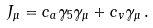Convert formula to latex. <formula><loc_0><loc_0><loc_500><loc_500>J _ { \mu } = c _ { a } \gamma _ { 5 } \gamma _ { \mu } + c _ { v } \gamma _ { \mu } \, .</formula> 